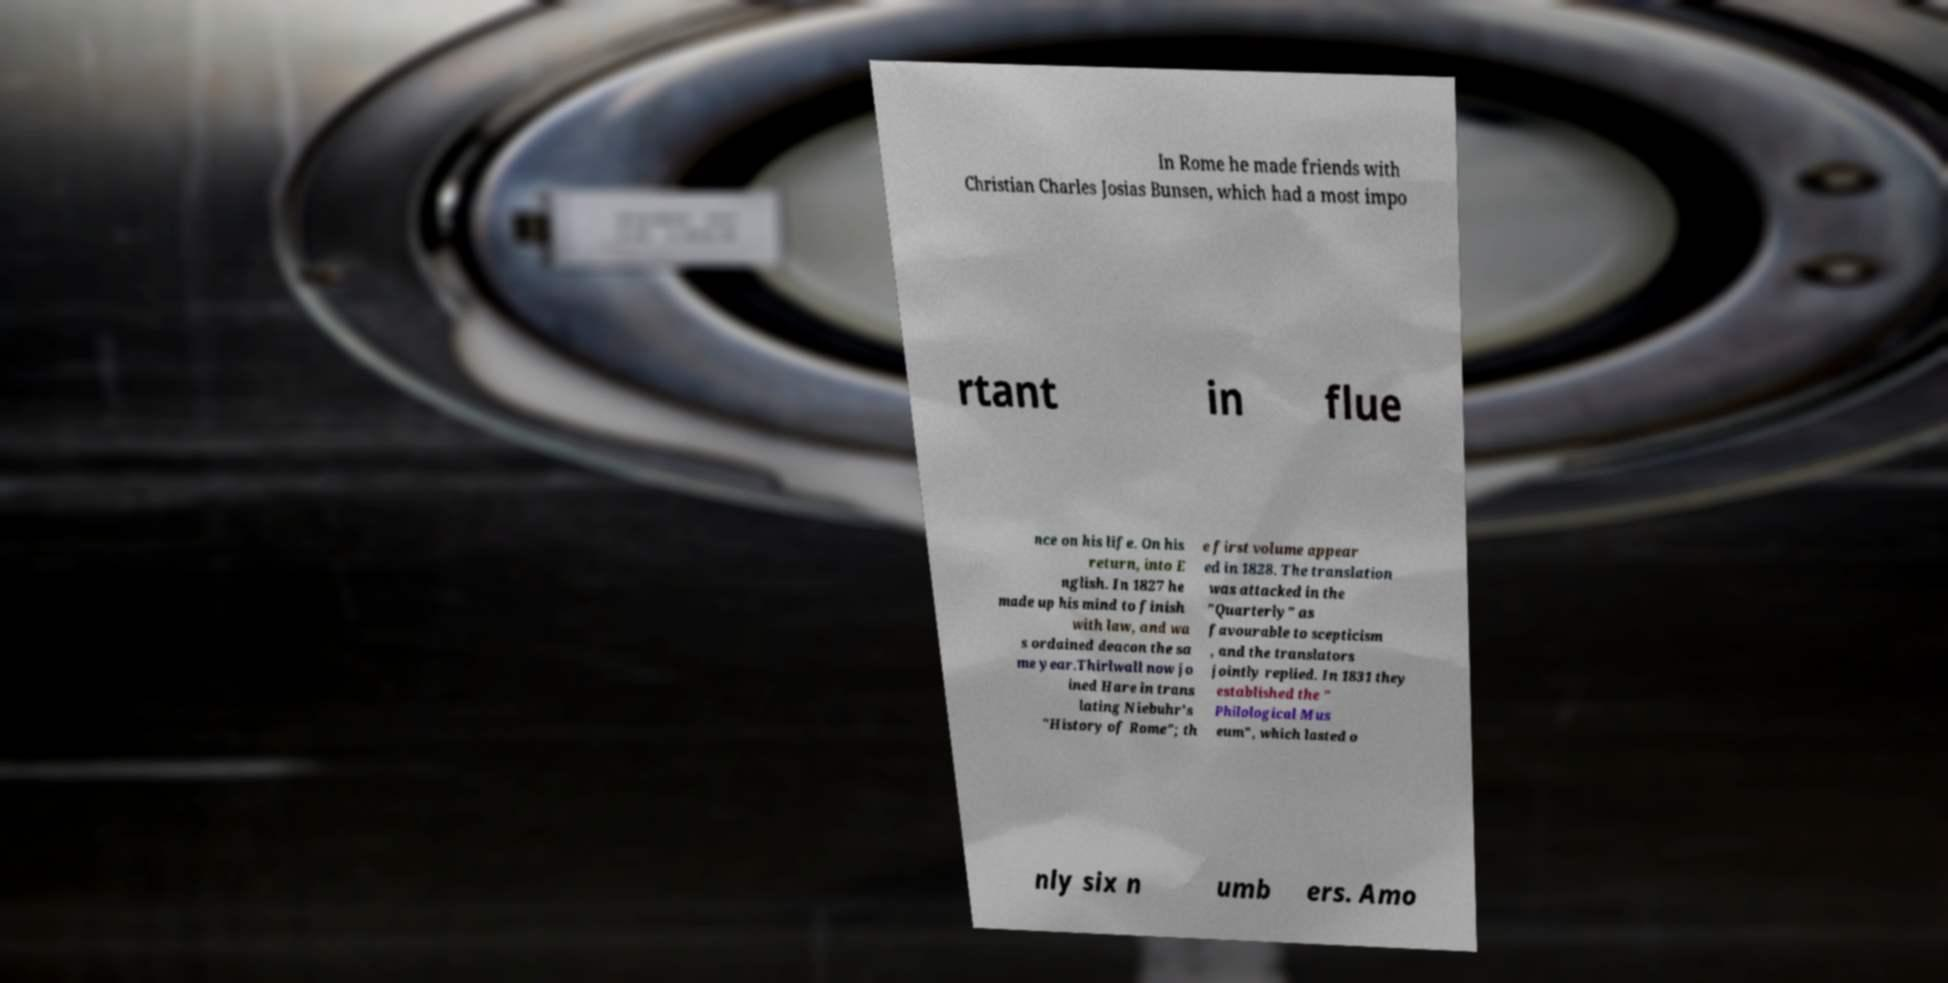Can you read and provide the text displayed in the image?This photo seems to have some interesting text. Can you extract and type it out for me? In Rome he made friends with Christian Charles Josias Bunsen, which had a most impo rtant in flue nce on his life. On his return, into E nglish. In 1827 he made up his mind to finish with law, and wa s ordained deacon the sa me year.Thirlwall now jo ined Hare in trans lating Niebuhr's "History of Rome"; th e first volume appear ed in 1828. The translation was attacked in the "Quarterly" as favourable to scepticism , and the translators jointly replied. In 1831 they established the " Philological Mus eum", which lasted o nly six n umb ers. Amo 